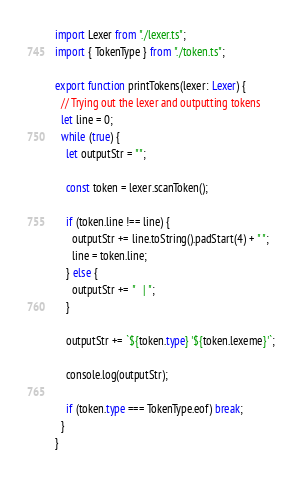Convert code to text. <code><loc_0><loc_0><loc_500><loc_500><_TypeScript_>import Lexer from "./lexer.ts";
import { TokenType } from "./token.ts";

export function printTokens(lexer: Lexer) {
  // Trying out the lexer and outputting tokens
  let line = 0;
  while (true) {
    let outputStr = "";

    const token = lexer.scanToken();

    if (token.line !== line) {
      outputStr += line.toString().padStart(4) + " ";
      line = token.line;
    } else {
      outputStr += "   | ";
    }

    outputStr += `${token.type} '${token.lexeme}'`;

    console.log(outputStr);

    if (token.type === TokenType.eof) break;
  }
}
</code> 